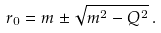<formula> <loc_0><loc_0><loc_500><loc_500>r _ { 0 } = m \pm \sqrt { m ^ { 2 } - Q ^ { 2 } } \, .</formula> 